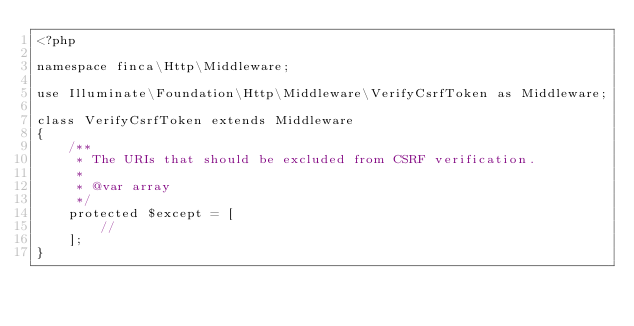<code> <loc_0><loc_0><loc_500><loc_500><_PHP_><?php

namespace finca\Http\Middleware;

use Illuminate\Foundation\Http\Middleware\VerifyCsrfToken as Middleware;

class VerifyCsrfToken extends Middleware
{
    /**
     * The URIs that should be excluded from CSRF verification.
     *
     * @var array
     */
    protected $except = [
        //
    ];
}
</code> 